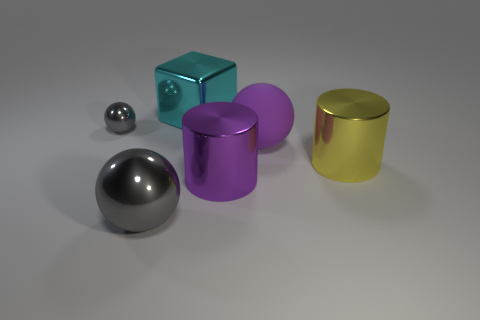Do the sphere that is in front of the purple matte object and the tiny metal sphere have the same size?
Make the answer very short. No. How big is the yellow cylinder on the right side of the gray thing that is in front of the small gray metal thing?
Ensure brevity in your answer.  Large. How many purple things are large matte objects or tiny shiny objects?
Provide a short and direct response. 1. Are there fewer purple shiny cylinders that are on the right side of the big cyan metal cube than large objects to the left of the big purple matte thing?
Provide a short and direct response. Yes. There is a rubber ball; is its size the same as the gray metallic object that is behind the purple metallic thing?
Ensure brevity in your answer.  No. What number of purple objects are the same size as the yellow object?
Keep it short and to the point. 2. How many tiny objects are either yellow things or shiny spheres?
Ensure brevity in your answer.  1. Are any tiny cyan shiny cubes visible?
Make the answer very short. No. Are there more big cubes that are on the right side of the tiny ball than tiny things that are on the right side of the big purple metal cylinder?
Your response must be concise. Yes. The big sphere on the right side of the purple object that is on the left side of the large purple matte ball is what color?
Provide a succinct answer. Purple. 